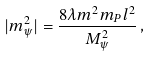Convert formula to latex. <formula><loc_0><loc_0><loc_500><loc_500>| m _ { \psi } ^ { 2 } | = \frac { 8 \lambda m ^ { 2 } m _ { P } l ^ { 2 } } { M _ { \psi } ^ { 2 } } \, ,</formula> 